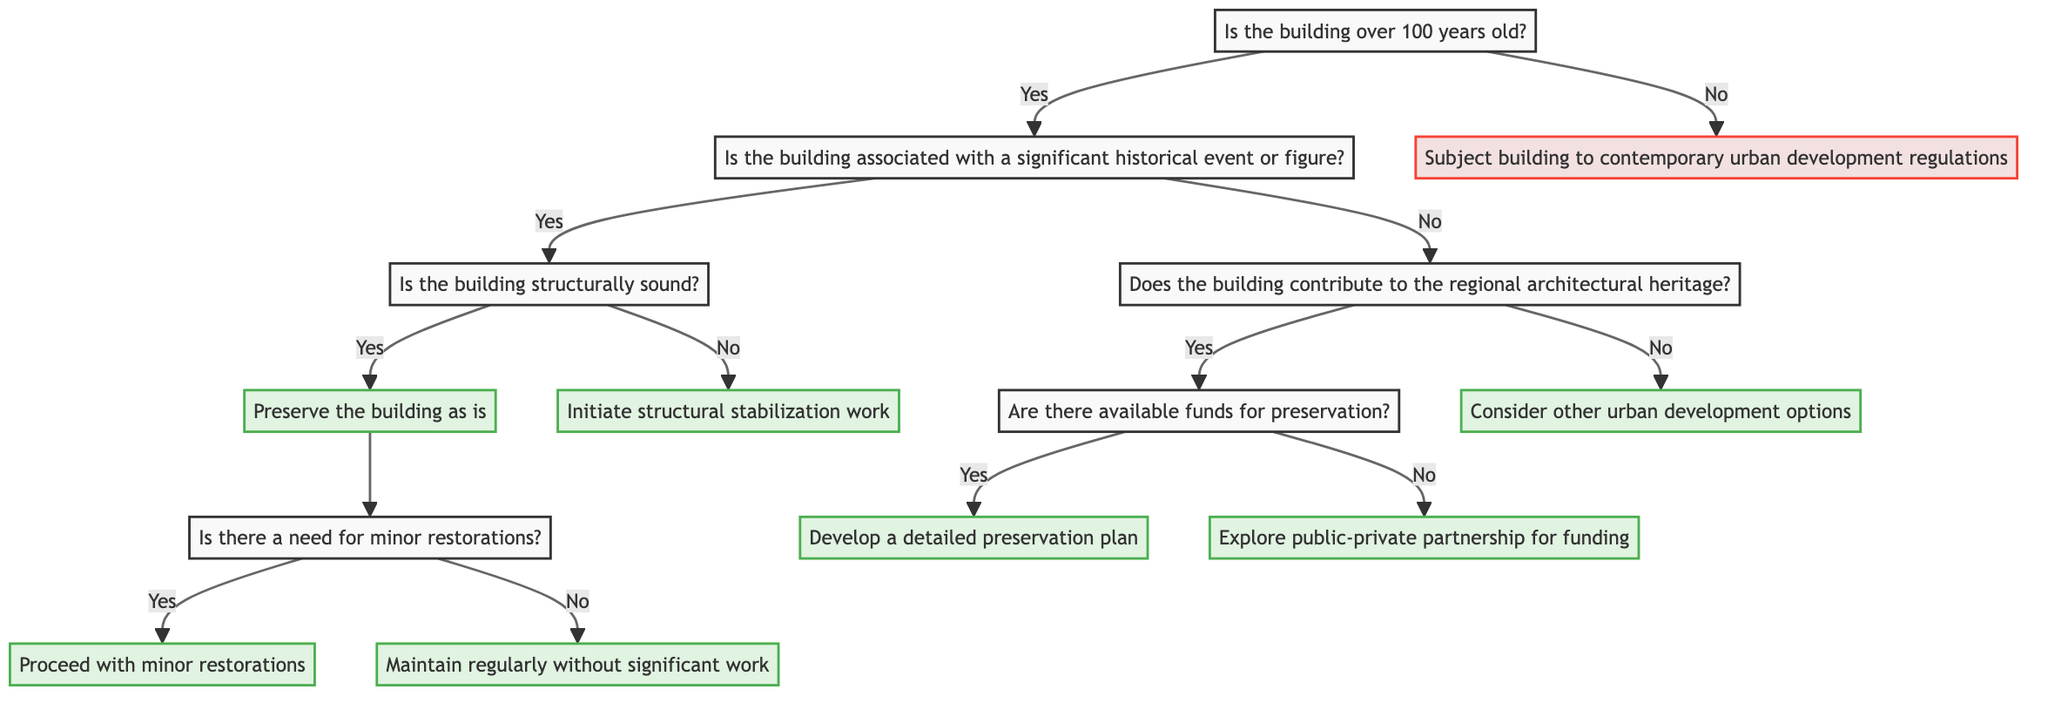Is the first question in the diagram about age? Yes, the first question in the diagram is "Is the building over 100 years old?" which determines the initial path of the decision tree.
Answer: Yes How many major branches are there after the first question? After the first question, there are two main branches: one leading to the "Yes" pathway and the other to the "No" pathway.
Answer: Two What happens if a building is not over 100 years old? If a building is not over 100 years old, the decision made is to "Subject building to contemporary urban development regulations.”
Answer: Subject building to contemporary urban development regulations If a building is associated with a significant historical event but not structurally sound, what action is taken? If a building is associated with a significant historical event but deemed not structurally sound, the next action taken is "Initiate structural stabilization work."
Answer: Initiate structural stabilization work What is the outcome if a building contributes to regional architectural heritage but there are no available funds? If a building contributes to regional architectural heritage and there are no available funds, the next step is to "Explore public-private partnership for funding."
Answer: Explore public-private partnership for funding How many steps are required to reach the decision to "Maintain regularly without significant work"? To reach the decision to "Maintain regularly without significant work," one needs to answer four questions: Is the building over 100 years old? (Yes) -> Is the building associated with a significant historical event or figure? (Yes) -> Is the building structurally sound? (Yes) -> Is there a need for minor restorations? (No).
Answer: Four What is the final decision after performing minor restorations? The final decision after performing minor restorations is not specified, but it can be inferred that regular maintenance would continue after minor restorations are completed.
Answer: Maintain regularly without significant work What indicates that a building has both historical significance and structural integrity? A building is indicated to have both historical significance and structural integrity if the responses to the questions are "Yes" to both "Is the building associated with a significant historical event or figure?" and "Is the building structurally sound?"
Answer: Preserve the building as is 